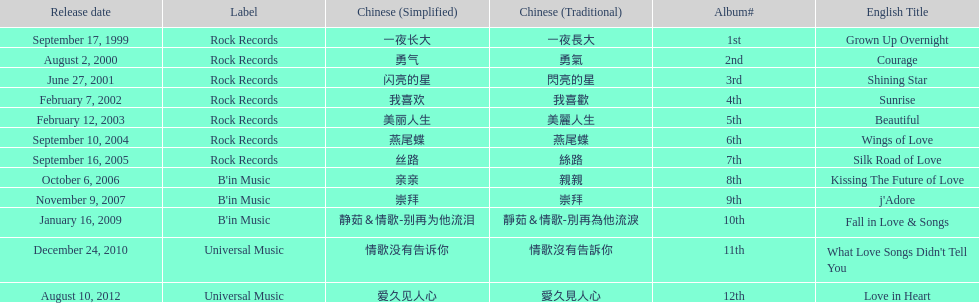What is the name of her last album produced with rock records? Silk Road of Love. 